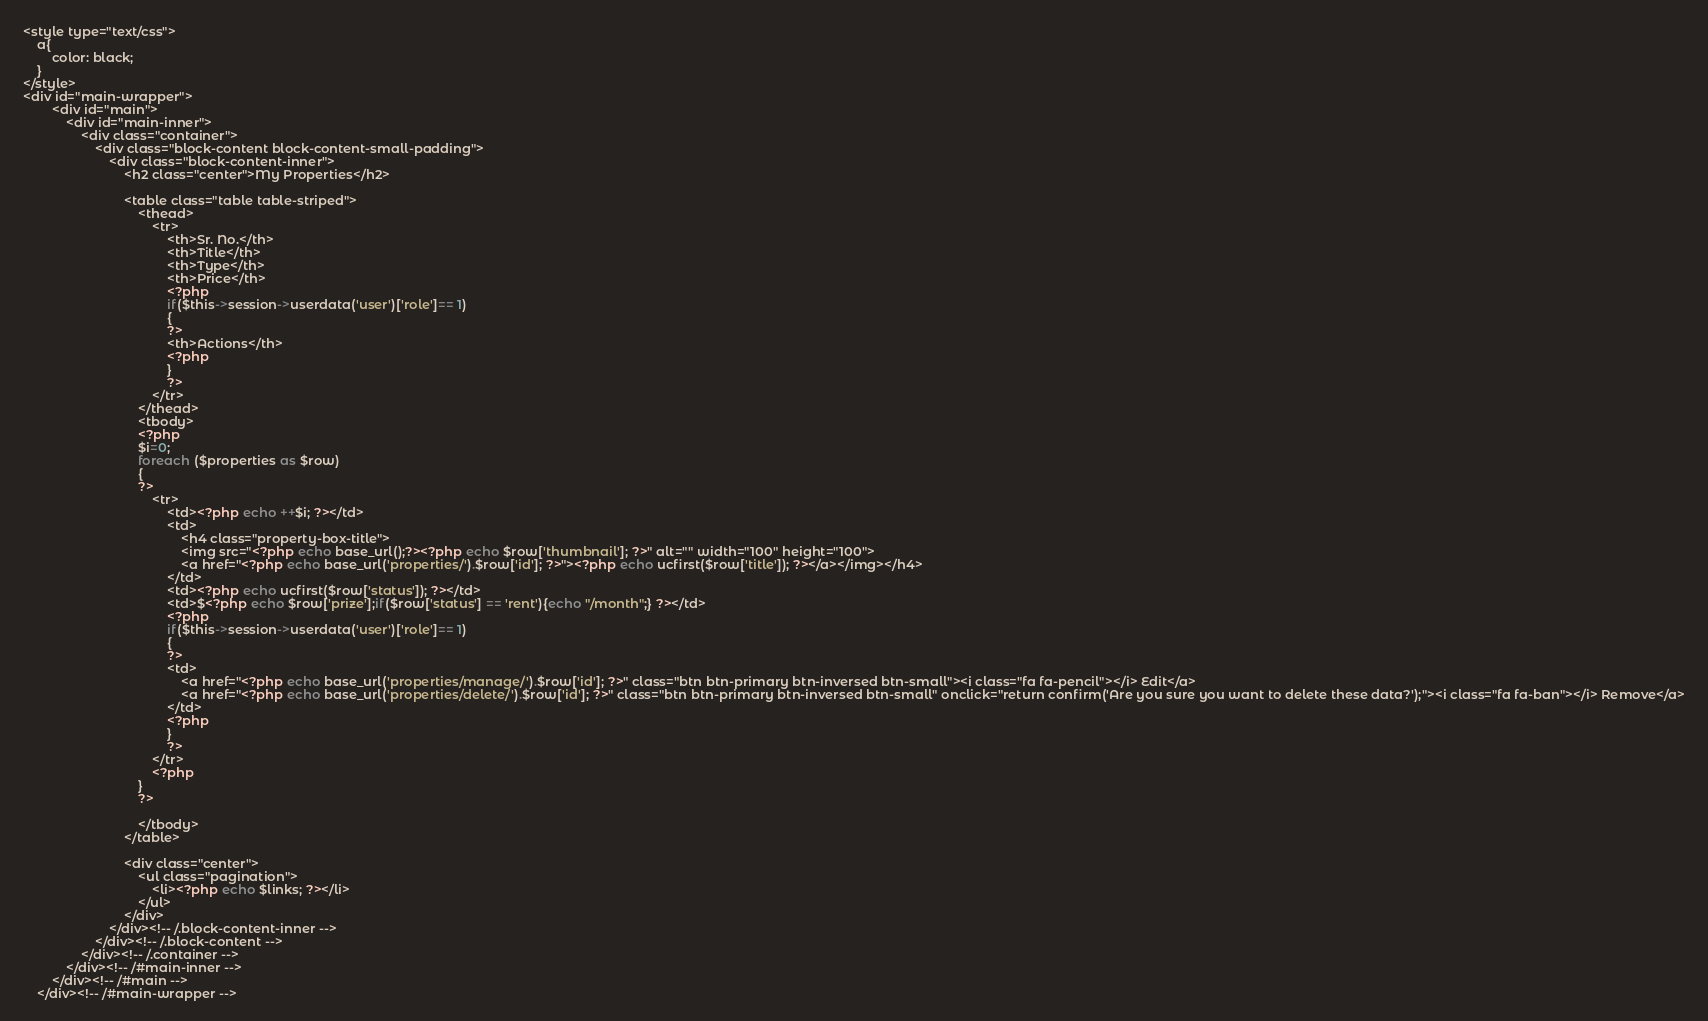Convert code to text. <code><loc_0><loc_0><loc_500><loc_500><_PHP_><style type="text/css">
    a{
        color: black;
    }
</style>
<div id="main-wrapper">
        <div id="main">
            <div id="main-inner">
                <div class="container">
                    <div class="block-content block-content-small-padding">
                        <div class="block-content-inner">
                            <h2 class="center">My Properties</h2>

                            <table class="table table-striped">
                                <thead>
                                    <tr>
                                        <th>Sr. No.</th>
                                        <th>Title</th>
                                        <th>Type</th>
                                        <th>Price</th>
                                        <?php
                                        if($this->session->userdata('user')['role']== 1)
                                        {
                                        ?>
                                        <th>Actions</th>
                                        <?php
                                        }
                                        ?>
                                    </tr>
                                </thead>
                                <tbody>
                                <?php
                                $i=0;
                                foreach ($properties as $row) 
                                {
                                ?>
                                    <tr>
                                        <td><?php echo ++$i; ?></td>
                                        <td>
                                            <h4 class="property-box-title">
                                            <img src="<?php echo base_url();?><?php echo $row['thumbnail']; ?>" alt="" width="100" height="100">
                                            <a href="<?php echo base_url('properties/').$row['id']; ?>"><?php echo ucfirst($row['title']); ?></a></img></h4>
                                        </td>
                                        <td><?php echo ucfirst($row['status']); ?></td>
                                        <td>$<?php echo $row['prize'];if($row['status'] == 'rent'){echo "/month";} ?></td>
                                        <?php
                                        if($this->session->userdata('user')['role']== 1)
                                        {
                                        ?>
                                        <td>
                                            <a href="<?php echo base_url('properties/manage/').$row['id']; ?>" class="btn btn-primary btn-inversed btn-small"><i class="fa fa-pencil"></i> Edit</a>
                                            <a href="<?php echo base_url('properties/delete/').$row['id']; ?>" class="btn btn-primary btn-inversed btn-small" onclick="return confirm('Are you sure you want to delete these data?');"><i class="fa fa-ban"></i> Remove</a>
                                        </td>
                                        <?php
                                        }
                                        ?>
                                    </tr>
                                    <?php
                                }
                                ?>
                                    
                                </tbody>
                            </table>

                            <div class="center">
                                <ul class="pagination">
                                    <li><?php echo $links; ?></li>
                                </ul>
                            </div>
                        </div><!-- /.block-content-inner -->
                    </div><!-- /.block-content -->
                </div><!-- /.container -->
            </div><!-- /#main-inner -->
        </div><!-- /#main -->
    </div><!-- /#main-wrapper -->
</code> 